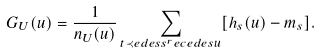<formula> <loc_0><loc_0><loc_500><loc_500>G _ { U } ( u ) = \frac { 1 } { n _ { U } ( u ) } \sum _ { t \prec e d e s s ^ { r } e c e d e s u } [ h _ { s } ( u ) - m _ { s } ] .</formula> 